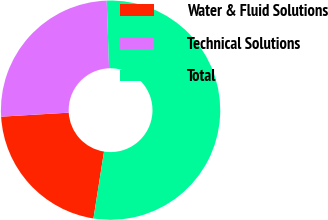Convert chart to OTSL. <chart><loc_0><loc_0><loc_500><loc_500><pie_chart><fcel>Water & Fluid Solutions<fcel>Technical Solutions<fcel>Total<nl><fcel>21.56%<fcel>25.38%<fcel>53.05%<nl></chart> 